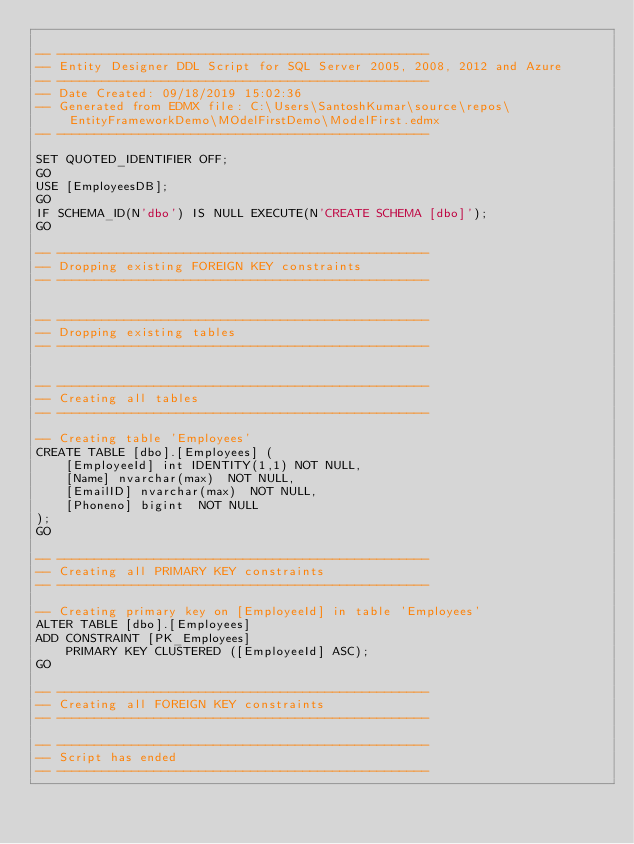Convert code to text. <code><loc_0><loc_0><loc_500><loc_500><_SQL_>
-- --------------------------------------------------
-- Entity Designer DDL Script for SQL Server 2005, 2008, 2012 and Azure
-- --------------------------------------------------
-- Date Created: 09/18/2019 15:02:36
-- Generated from EDMX file: C:\Users\SantoshKumar\source\repos\EntityFrameworkDemo\MOdelFirstDemo\ModelFirst.edmx
-- --------------------------------------------------

SET QUOTED_IDENTIFIER OFF;
GO
USE [EmployeesDB];
GO
IF SCHEMA_ID(N'dbo') IS NULL EXECUTE(N'CREATE SCHEMA [dbo]');
GO

-- --------------------------------------------------
-- Dropping existing FOREIGN KEY constraints
-- --------------------------------------------------


-- --------------------------------------------------
-- Dropping existing tables
-- --------------------------------------------------


-- --------------------------------------------------
-- Creating all tables
-- --------------------------------------------------

-- Creating table 'Employees'
CREATE TABLE [dbo].[Employees] (
    [EmployeeId] int IDENTITY(1,1) NOT NULL,
    [Name] nvarchar(max)  NOT NULL,
    [EmailID] nvarchar(max)  NOT NULL,
    [Phoneno] bigint  NOT NULL
);
GO

-- --------------------------------------------------
-- Creating all PRIMARY KEY constraints
-- --------------------------------------------------

-- Creating primary key on [EmployeeId] in table 'Employees'
ALTER TABLE [dbo].[Employees]
ADD CONSTRAINT [PK_Employees]
    PRIMARY KEY CLUSTERED ([EmployeeId] ASC);
GO

-- --------------------------------------------------
-- Creating all FOREIGN KEY constraints
-- --------------------------------------------------

-- --------------------------------------------------
-- Script has ended
-- --------------------------------------------------</code> 